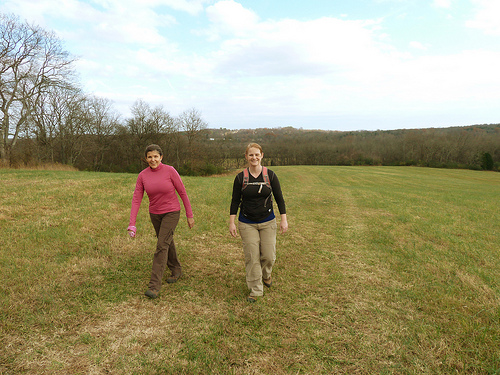<image>
Can you confirm if the woman is on the field? Yes. Looking at the image, I can see the woman is positioned on top of the field, with the field providing support. 